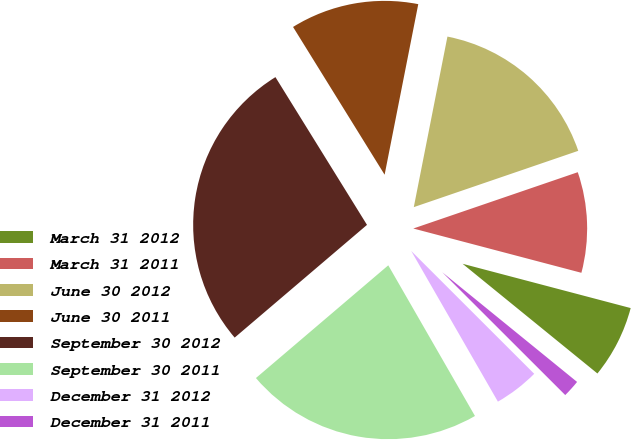Convert chart to OTSL. <chart><loc_0><loc_0><loc_500><loc_500><pie_chart><fcel>March 31 2012<fcel>March 31 2011<fcel>June 30 2012<fcel>June 30 2011<fcel>September 30 2012<fcel>September 30 2011<fcel>December 31 2012<fcel>December 31 2011<nl><fcel>6.77%<fcel>9.35%<fcel>16.65%<fcel>11.93%<fcel>27.4%<fcel>22.08%<fcel>4.2%<fcel>1.62%<nl></chart> 